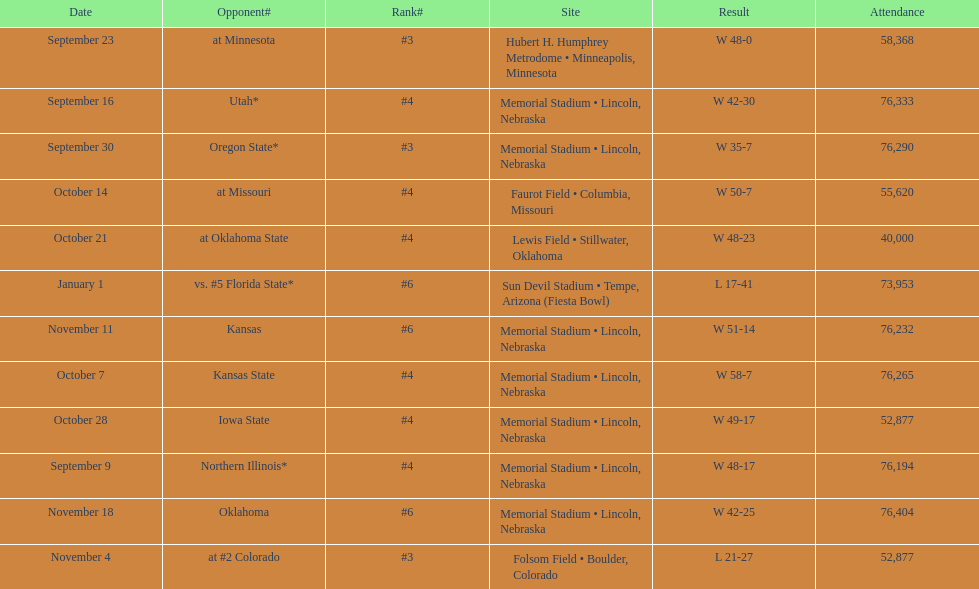How many games was their ranking not lower than #5? 9. 